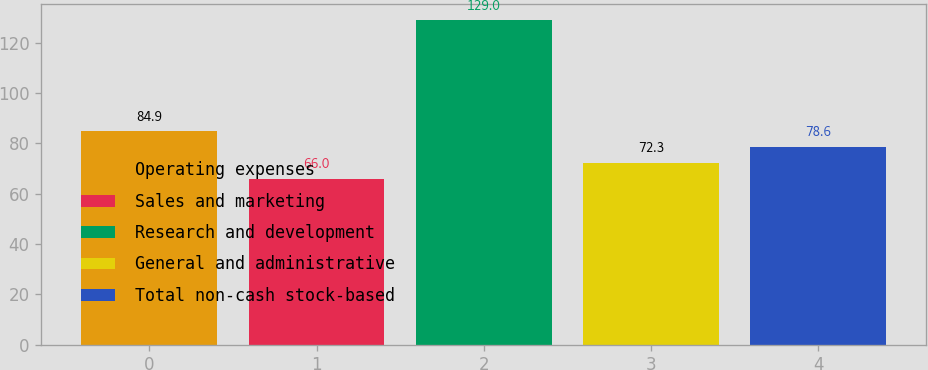Convert chart to OTSL. <chart><loc_0><loc_0><loc_500><loc_500><bar_chart><fcel>Operating expenses<fcel>Sales and marketing<fcel>Research and development<fcel>General and administrative<fcel>Total non-cash stock-based<nl><fcel>84.9<fcel>66<fcel>129<fcel>72.3<fcel>78.6<nl></chart> 